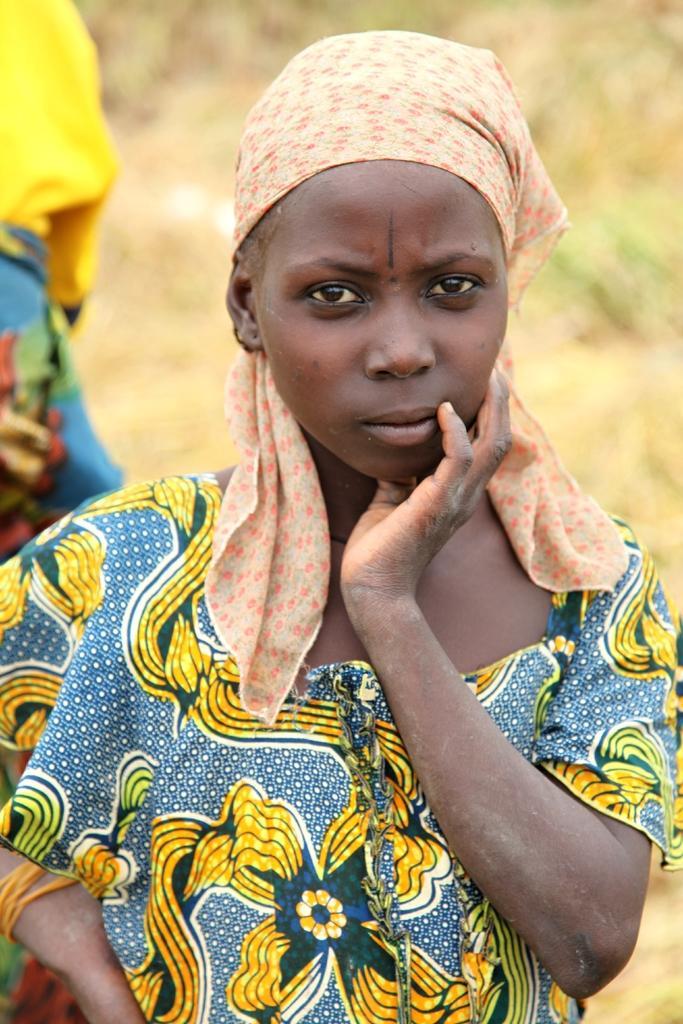How would you summarize this image in a sentence or two? In the picture I can see a woman wearing clothes. 